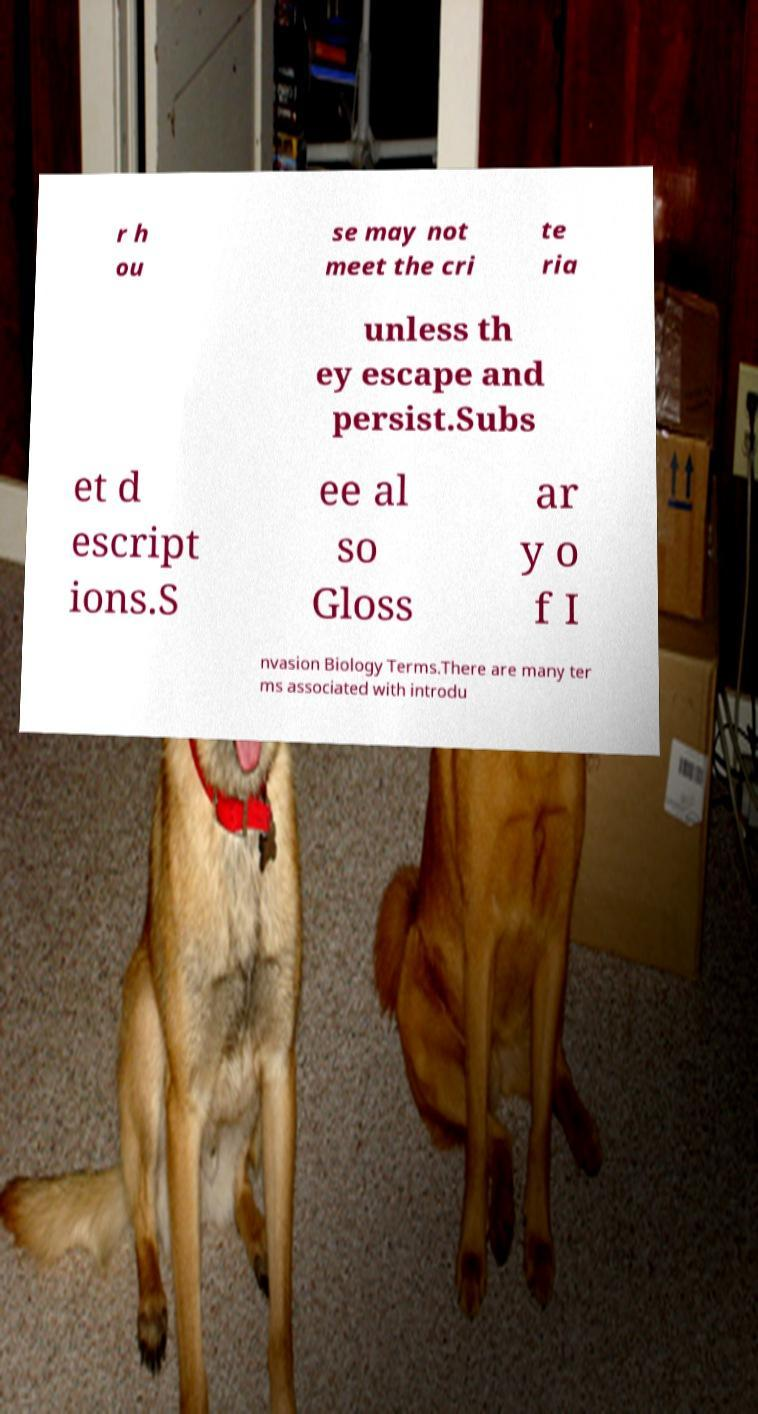What messages or text are displayed in this image? I need them in a readable, typed format. r h ou se may not meet the cri te ria unless th ey escape and persist.Subs et d escript ions.S ee al so Gloss ar y o f I nvasion Biology Terms.There are many ter ms associated with introdu 